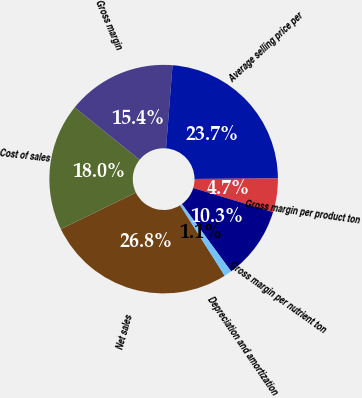Convert chart. <chart><loc_0><loc_0><loc_500><loc_500><pie_chart><fcel>Net sales<fcel>Cost of sales<fcel>Gross margin<fcel>Average selling price per<fcel>Gross margin per product ton<fcel>Gross margin per nutrient ton<fcel>Depreciation and amortization<nl><fcel>26.77%<fcel>18.0%<fcel>15.44%<fcel>23.67%<fcel>4.74%<fcel>10.3%<fcel>1.08%<nl></chart> 